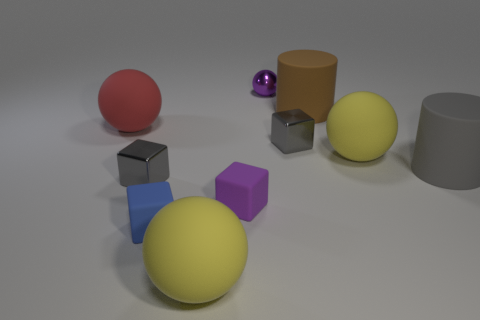Subtract all blue blocks. How many blocks are left? 3 Subtract all purple cubes. How many cubes are left? 3 Subtract all blue cubes. How many yellow spheres are left? 2 Subtract all balls. How many objects are left? 6 Subtract 2 spheres. How many spheres are left? 2 Add 9 small purple cubes. How many small purple cubes exist? 10 Subtract 1 red balls. How many objects are left? 9 Subtract all brown balls. Subtract all red cubes. How many balls are left? 4 Subtract all small rubber cubes. Subtract all purple shiny spheres. How many objects are left? 7 Add 4 large brown rubber objects. How many large brown rubber objects are left? 5 